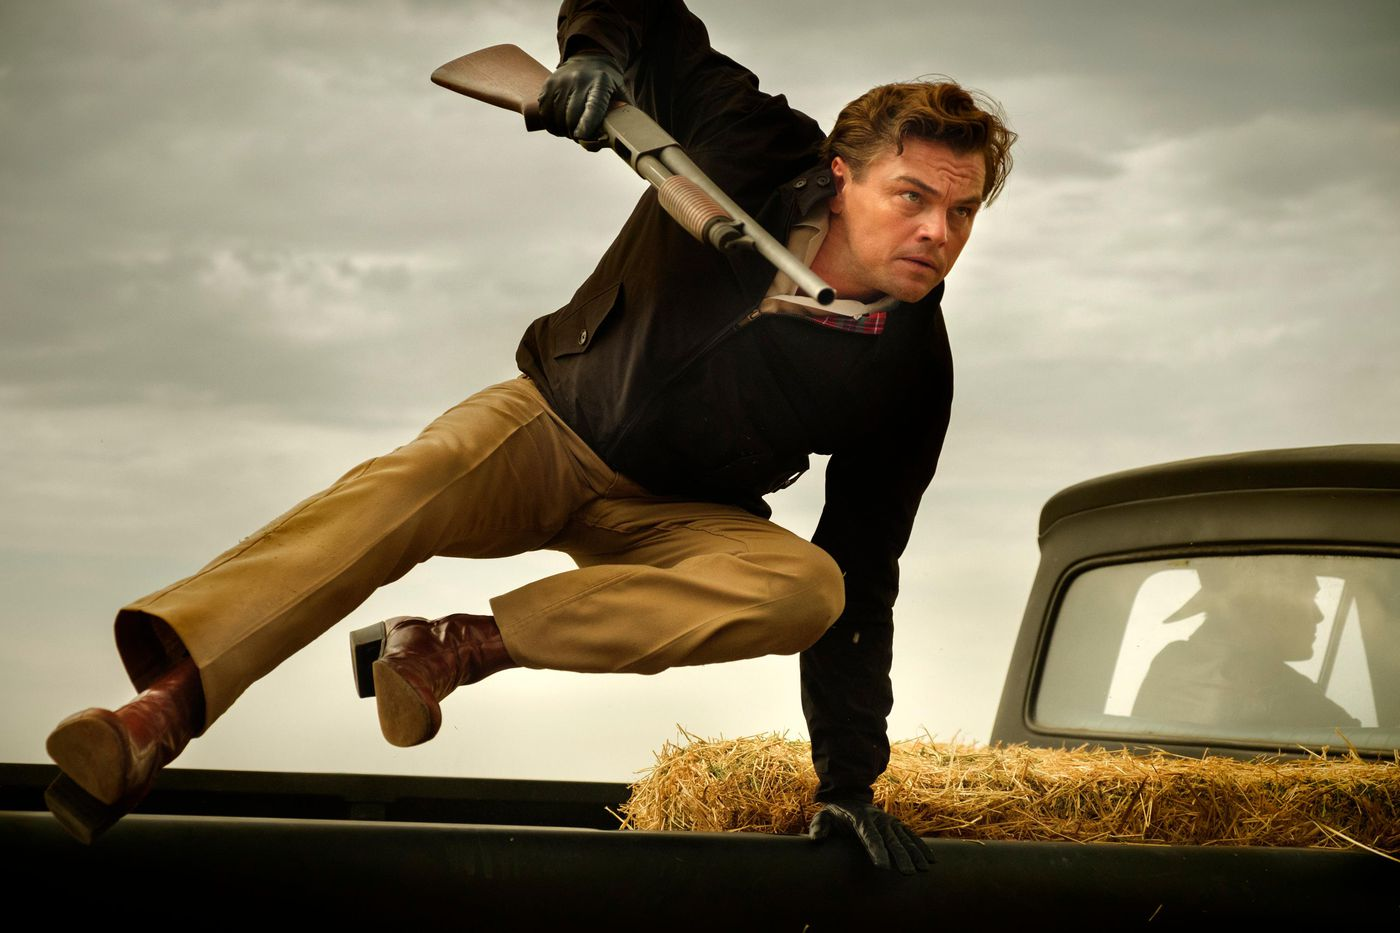What could be the story behind this image? The image likely captures a pivotal moment in a dramatic story, possibly involving a chase or a confrontation. The man, armed and in mid-leap over a hay-covered vintage car, appears ready for action, suggesting a narrative of urgency and tension. He could be escaping from danger, pursuing a target, or defending himself in a rural or remote setting. The clouds and the overall earthy palette hint at an isolated, rugged backdrop, enhancing the sense of an intense and possibly historical or rustic situation. 